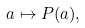Convert formula to latex. <formula><loc_0><loc_0><loc_500><loc_500>a \mapsto P ( a ) ,</formula> 